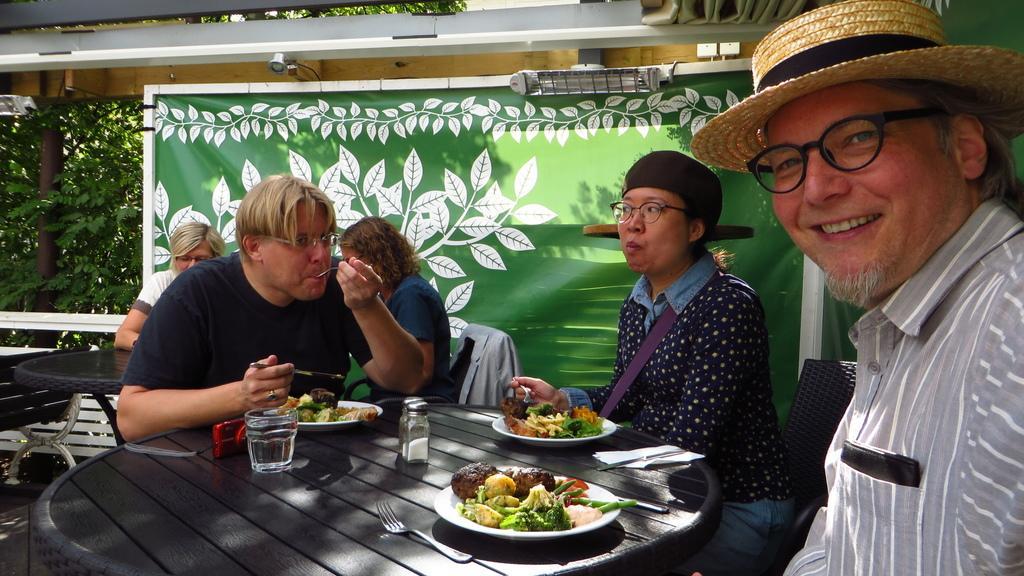Describe this image in one or two sentences. This picture shows a group of people seated on the chairs and a man wearing a hat and spectacles on his face and we see some food with plates and glass of water and a fork on the table we see a banner on the side and a tree 